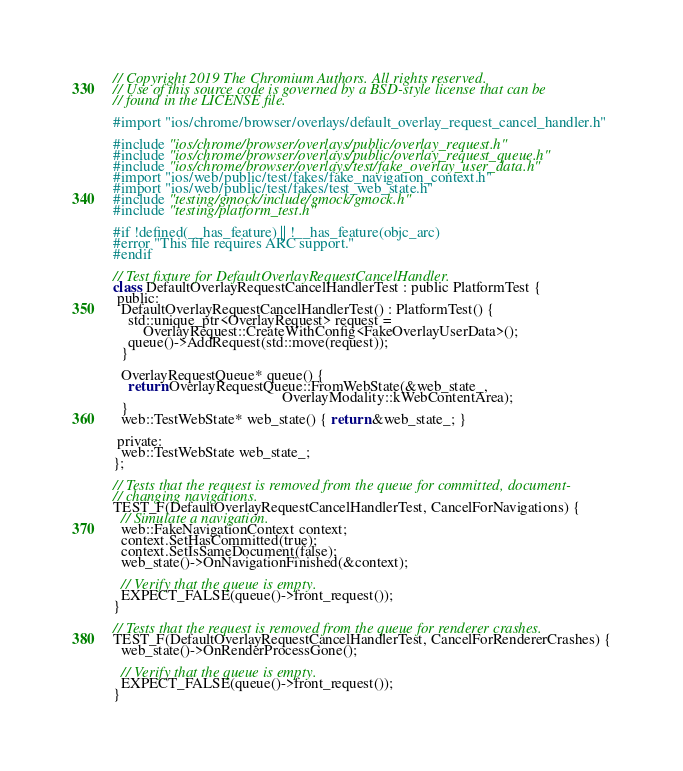Convert code to text. <code><loc_0><loc_0><loc_500><loc_500><_ObjectiveC_>// Copyright 2019 The Chromium Authors. All rights reserved.
// Use of this source code is governed by a BSD-style license that can be
// found in the LICENSE file.

#import "ios/chrome/browser/overlays/default_overlay_request_cancel_handler.h"

#include "ios/chrome/browser/overlays/public/overlay_request.h"
#include "ios/chrome/browser/overlays/public/overlay_request_queue.h"
#include "ios/chrome/browser/overlays/test/fake_overlay_user_data.h"
#import "ios/web/public/test/fakes/fake_navigation_context.h"
#import "ios/web/public/test/fakes/test_web_state.h"
#include "testing/gmock/include/gmock/gmock.h"
#include "testing/platform_test.h"

#if !defined(__has_feature) || !__has_feature(objc_arc)
#error "This file requires ARC support."
#endif

// Test fixture for DefaultOverlayRequestCancelHandler.
class DefaultOverlayRequestCancelHandlerTest : public PlatformTest {
 public:
  DefaultOverlayRequestCancelHandlerTest() : PlatformTest() {
    std::unique_ptr<OverlayRequest> request =
        OverlayRequest::CreateWithConfig<FakeOverlayUserData>();
    queue()->AddRequest(std::move(request));
  }

  OverlayRequestQueue* queue() {
    return OverlayRequestQueue::FromWebState(&web_state_,
                                             OverlayModality::kWebContentArea);
  }
  web::TestWebState* web_state() { return &web_state_; }

 private:
  web::TestWebState web_state_;
};

// Tests that the request is removed from the queue for committed, document-
// changing navigations.
TEST_F(DefaultOverlayRequestCancelHandlerTest, CancelForNavigations) {
  // Simulate a navigation.
  web::FakeNavigationContext context;
  context.SetHasCommitted(true);
  context.SetIsSameDocument(false);
  web_state()->OnNavigationFinished(&context);

  // Verify that the queue is empty.
  EXPECT_FALSE(queue()->front_request());
}

// Tests that the request is removed from the queue for renderer crashes.
TEST_F(DefaultOverlayRequestCancelHandlerTest, CancelForRendererCrashes) {
  web_state()->OnRenderProcessGone();

  // Verify that the queue is empty.
  EXPECT_FALSE(queue()->front_request());
}
</code> 